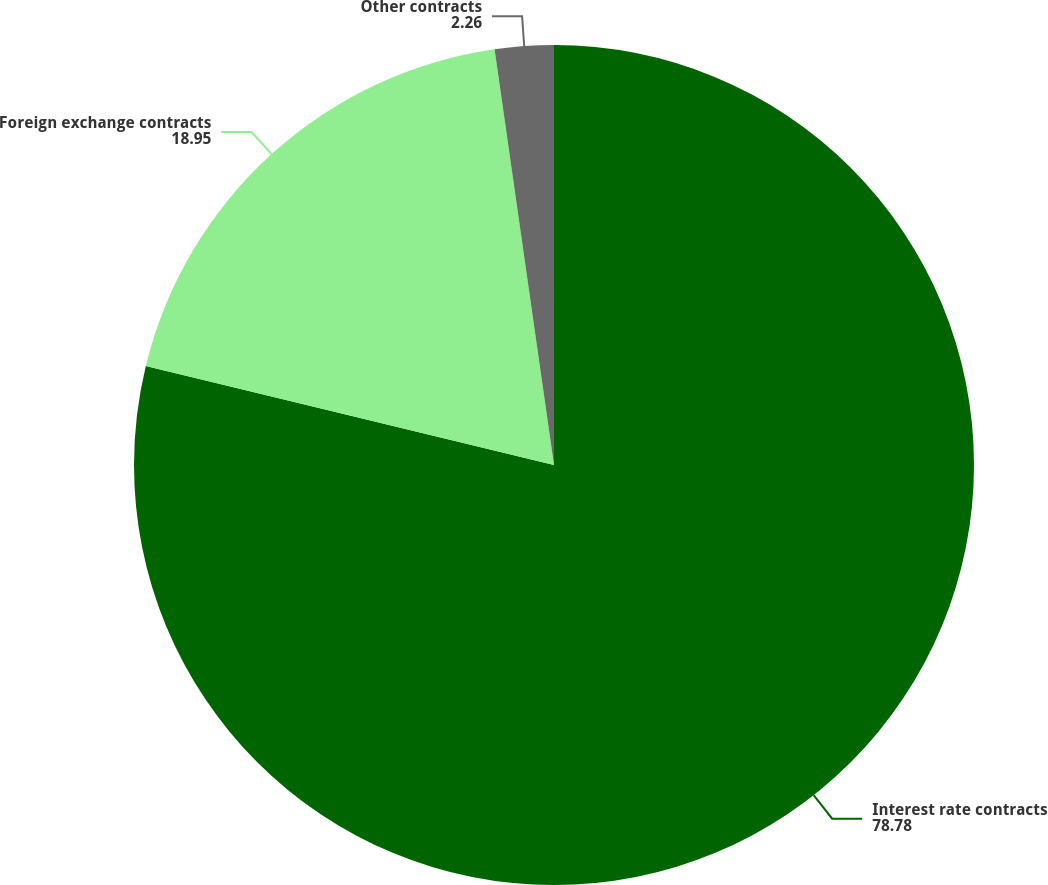<chart> <loc_0><loc_0><loc_500><loc_500><pie_chart><fcel>Interest rate contracts<fcel>Foreign exchange contracts<fcel>Other contracts<nl><fcel>78.78%<fcel>18.95%<fcel>2.26%<nl></chart> 